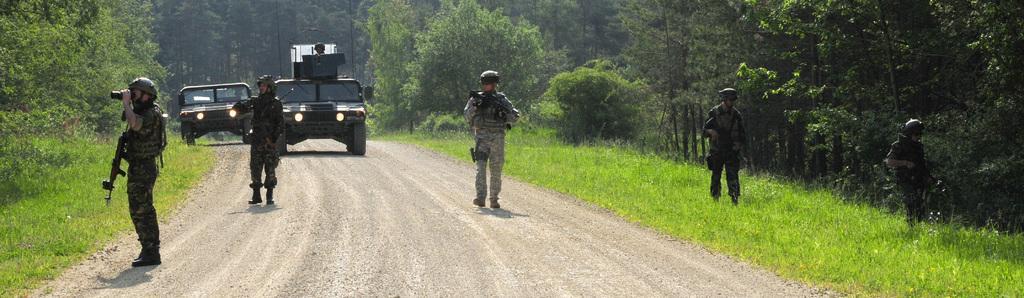Can you describe this image briefly? In this image we can see five persons are standing and they are holding guns. There is a person holding an object. Here we can see ground, grass, plants, vehicles, lights, and trees. We can see a person inside a vehicle. 